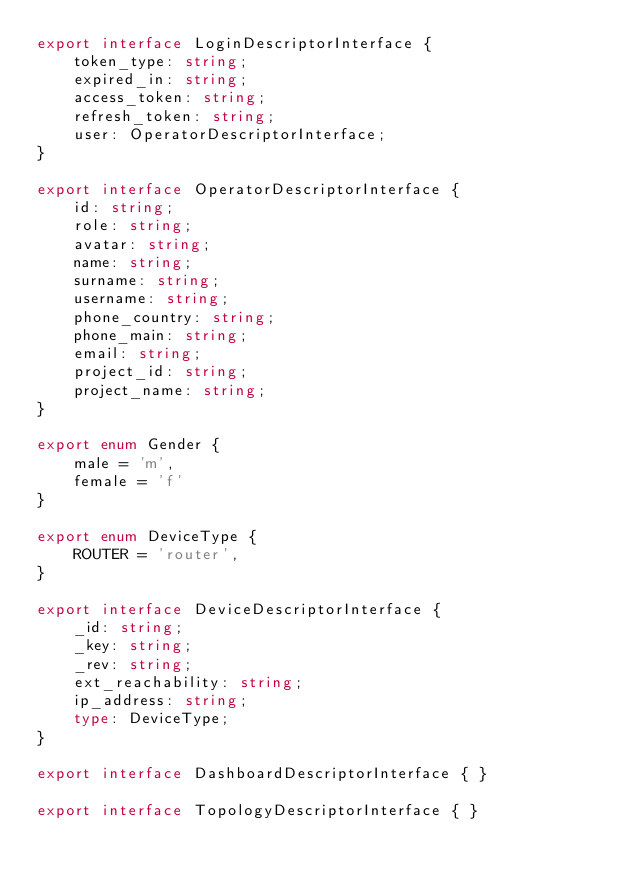<code> <loc_0><loc_0><loc_500><loc_500><_TypeScript_>export interface LoginDescriptorInterface {
    token_type: string;
    expired_in: string;
    access_token: string;
    refresh_token: string;
    user: OperatorDescriptorInterface;
}

export interface OperatorDescriptorInterface {
    id: string;
    role: string;
    avatar: string;
    name: string;
    surname: string;
    username: string;
    phone_country: string;
    phone_main: string;
    email: string;
    project_id: string;
    project_name: string;
}

export enum Gender {
    male = 'm',
    female = 'f'
}

export enum DeviceType {
    ROUTER = 'router',
}

export interface DeviceDescriptorInterface {
    _id: string;
    _key: string;
    _rev: string;
    ext_reachability: string;
    ip_address: string;
    type: DeviceType;
}

export interface DashboardDescriptorInterface { }

export interface TopologyDescriptorInterface { }</code> 